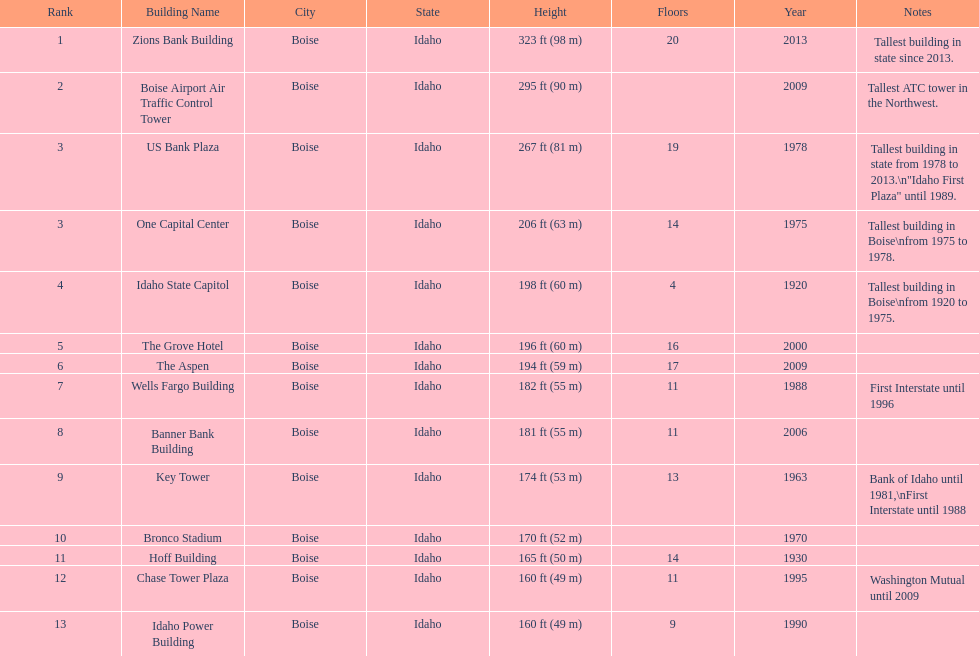What is the name of the last building on this chart? Idaho Power Building. 